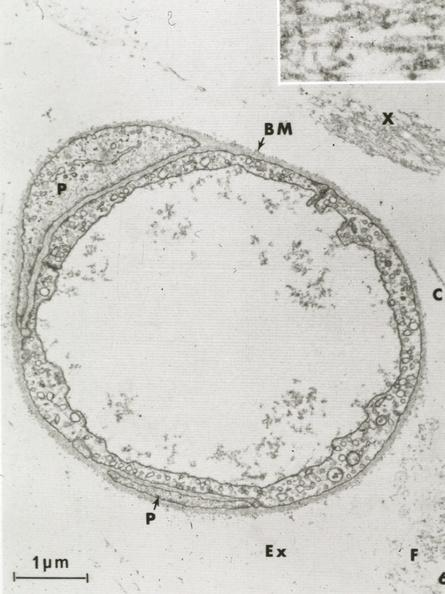what is present?
Answer the question using a single word or phrase. Vasculature 